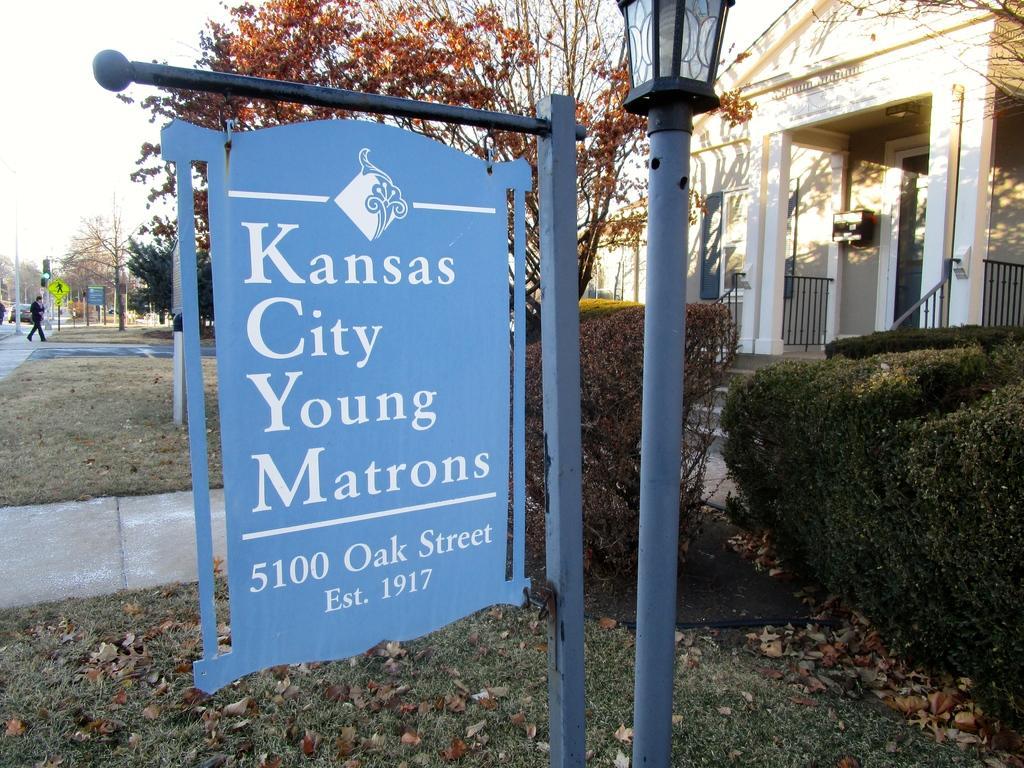Describe this image in one or two sentences. In this picture we can see board and light attached to the poles, grass, leaves, house, plants, trees and house. In the background of the image there is a person walking and we can see a car, poles, boards, traffic signal, trees and sky. 